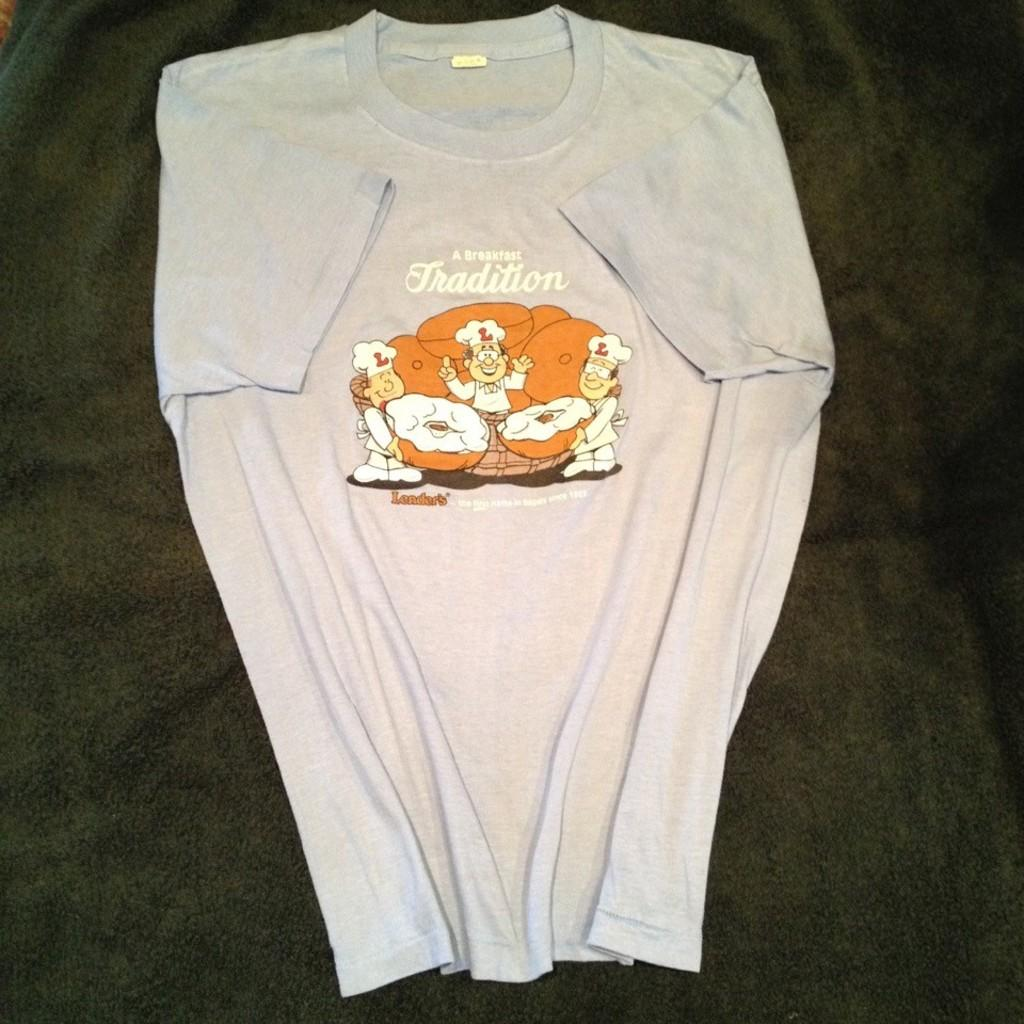What type of clothing is visible in the image? There is a white t-shirt in the image. What is the t-shirt placed on? The t-shirt is on a black surface. What is depicted on the t-shirt? There are three persons on the t-shirt. What are the persons doing in the image on the t-shirt? The persons are standing and holding doughnuts in their hands. What type of whip is being used by the persons on the t-shirt? There is no whip present in the image; the persons are holding doughnuts in their hands. 